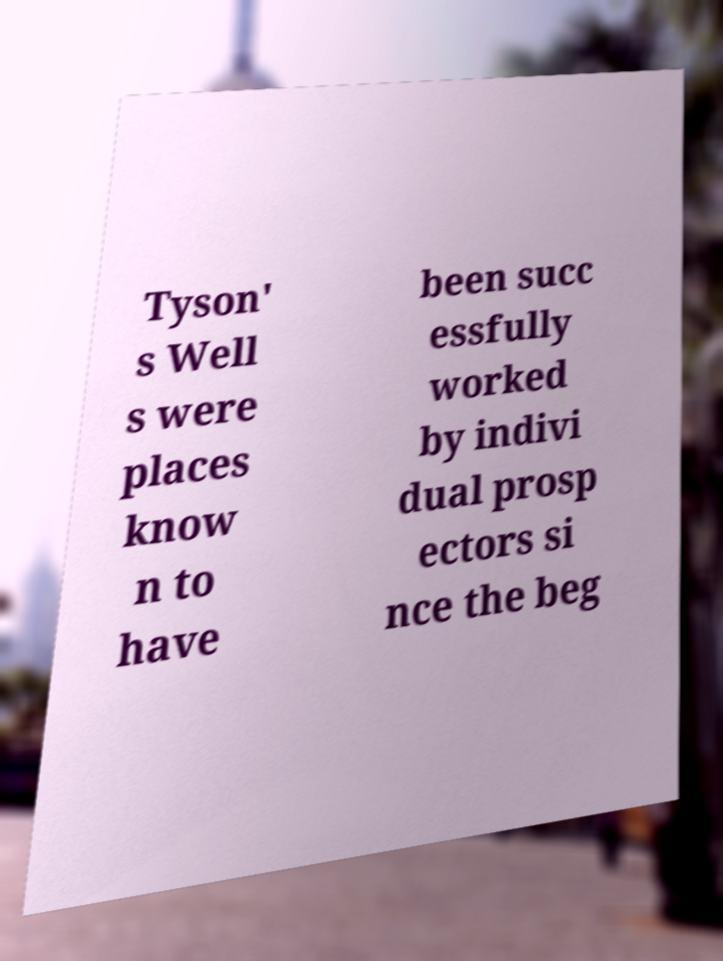Can you accurately transcribe the text from the provided image for me? Tyson' s Well s were places know n to have been succ essfully worked by indivi dual prosp ectors si nce the beg 